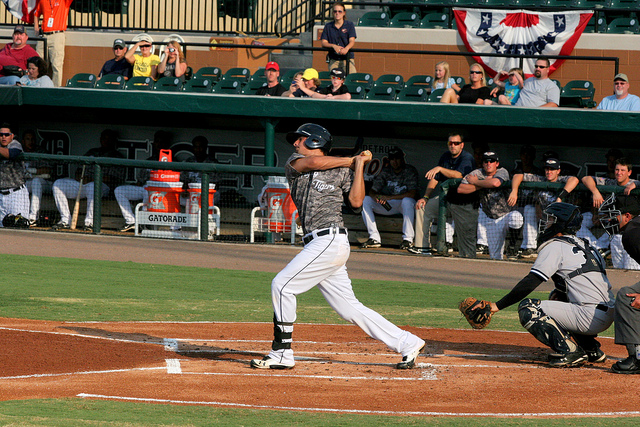Please transcribe the text information in this image. G GATORADE 